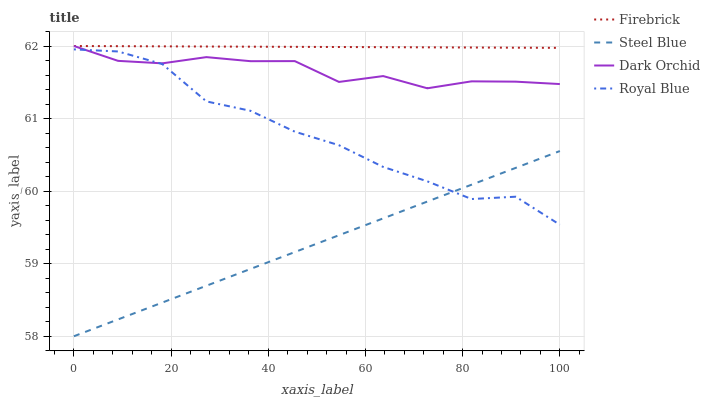Does Steel Blue have the minimum area under the curve?
Answer yes or no. Yes. Does Firebrick have the maximum area under the curve?
Answer yes or no. Yes. Does Firebrick have the minimum area under the curve?
Answer yes or no. No. Does Steel Blue have the maximum area under the curve?
Answer yes or no. No. Is Firebrick the smoothest?
Answer yes or no. Yes. Is Royal Blue the roughest?
Answer yes or no. Yes. Is Steel Blue the smoothest?
Answer yes or no. No. Is Steel Blue the roughest?
Answer yes or no. No. Does Firebrick have the lowest value?
Answer yes or no. No. Does Steel Blue have the highest value?
Answer yes or no. No. Is Royal Blue less than Firebrick?
Answer yes or no. Yes. Is Dark Orchid greater than Steel Blue?
Answer yes or no. Yes. Does Royal Blue intersect Firebrick?
Answer yes or no. No. 